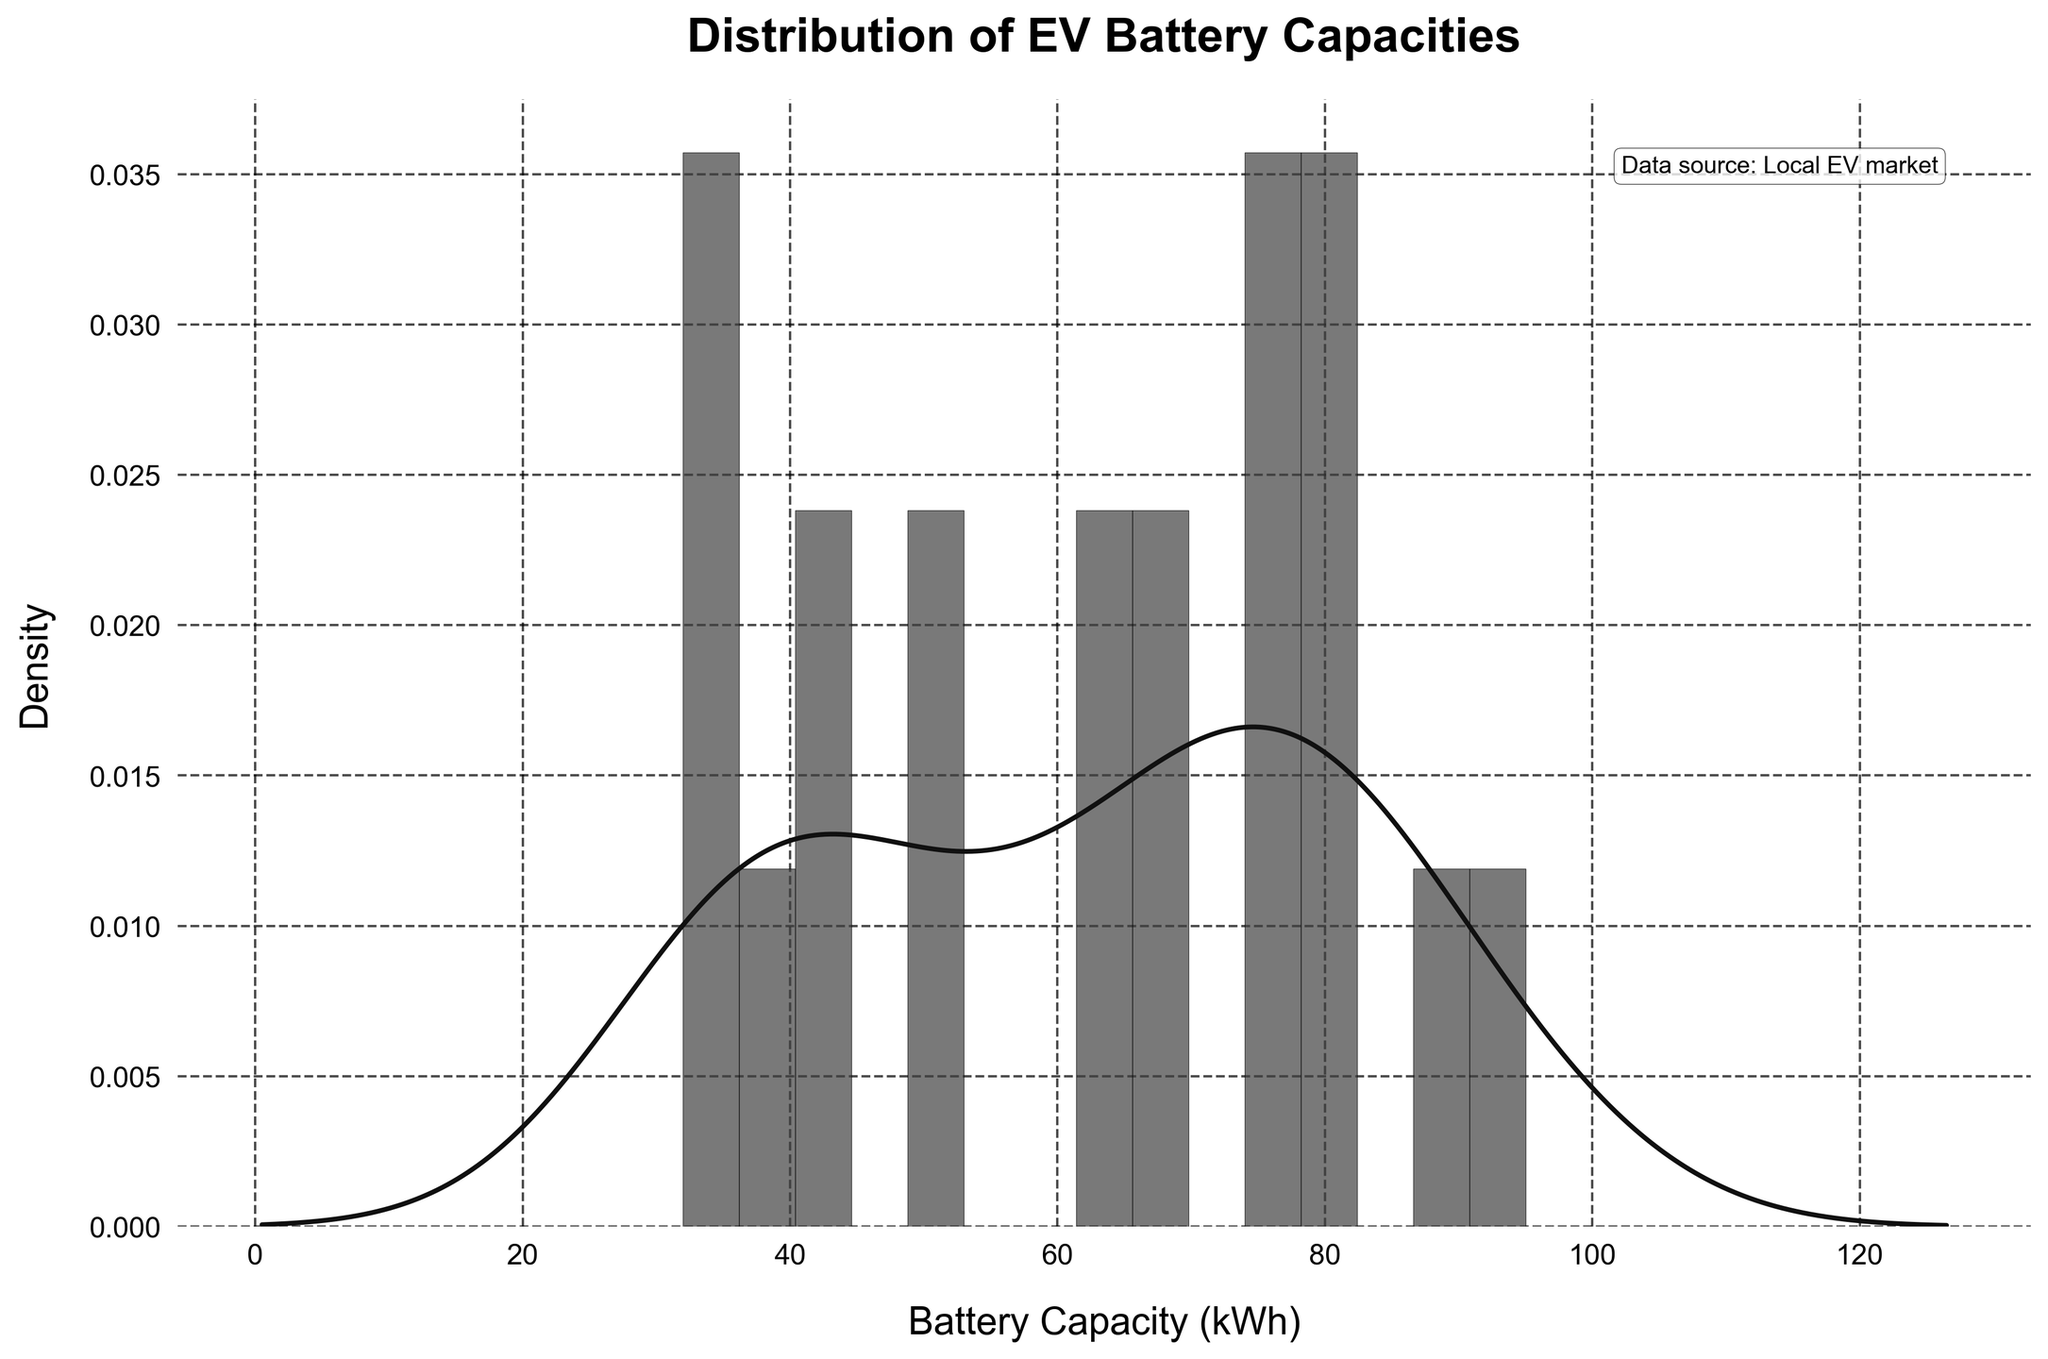What is the title of the histogram? The title is located at the top of the figure. By reading it, we find the title.
Answer: Distribution of EV Battery Capacities What is the unit of the x-axis? The label for the x-axis indicates the unit of measurement.
Answer: kWh How many bars are present in the histogram? Count the number of bars in the histogram directly from the figure.
Answer: 15 Which battery capacity range has the highest frequency in the histogram? Identify the bar with the tallest height, as it represents the range with the highest frequency.
Answer: 60-70 kWh What does the density curve (KDE) represent in the context of the histogram? The KDE smoothly estimates the probability density function of the random variable (battery capacity) and shows where data points are concentrated.
Answer: It represents the estimated density of battery capacities Do more vehicles have a battery capacity below or above 50 kWh? Compare the height of the bars and the area under the density curve to the left and right of 50 kWh.
Answer: Above 50 kWh What is the approximate range of battery capacities for the majority of electric vehicles in the local market? Identify the interval where the density curve (KDE) is widest and highest, indicating the concentration of most data points.
Answer: Between 30 and 95 kWh How does the KDE help in understanding the distribution of battery capacities as compared to just the histogram? Describe how the KDE provides a smoother view of data distribution, highlighting peaks and valleys that might not be clear from the histogram alone.
Answer: The KDE shows a smooth estimate of data density and highlights trends and patterns that are less visible in the histogram What can you infer about the future requirements for installing EV charging stations based on the distribution of battery capacities? Differentiate that more vehicles with higher or lower battery capacities impact the number and power level of EV charging stations.
Answer: Higher battery capacities necessitate more high-power charging stations How does the annotation in the top right corner add value to the figure? It gives context and authenticity by informing viewers of the data source, enhancing trust in the information presented.
Answer: It indicates that data is from the local EV market, enhancing credibility 